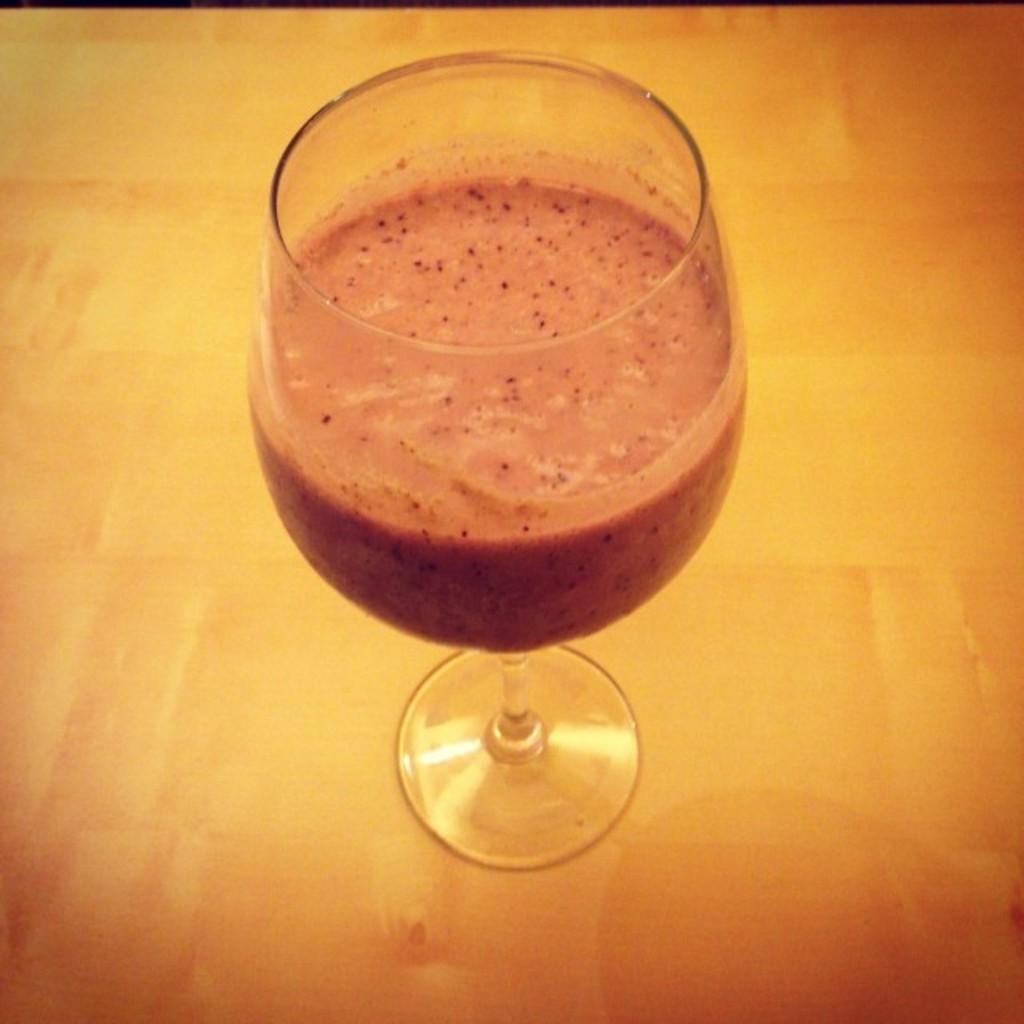What is inside the glass that is visible in the image? There is a glass filled with a liquid in the image. What is on top of the liquid in the glass? There are ingredients on top of the liquid in the glass. Where is the glass placed in the image? The glass is placed on a surface. What type of plastic branch can be seen in the image? There is no plastic branch present in the image. What verse is being recited by the person in the image? There is no person or verse present in the image. 